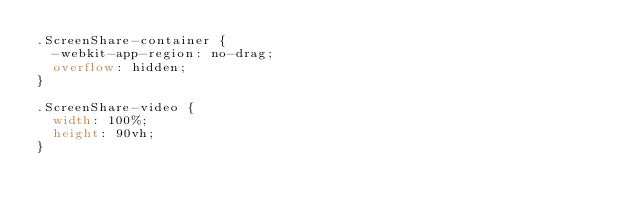Convert code to text. <code><loc_0><loc_0><loc_500><loc_500><_CSS_>.ScreenShare-container {
  -webkit-app-region: no-drag;
  overflow: hidden;
}

.ScreenShare-video {
  width: 100%;
  height: 90vh;
}
</code> 